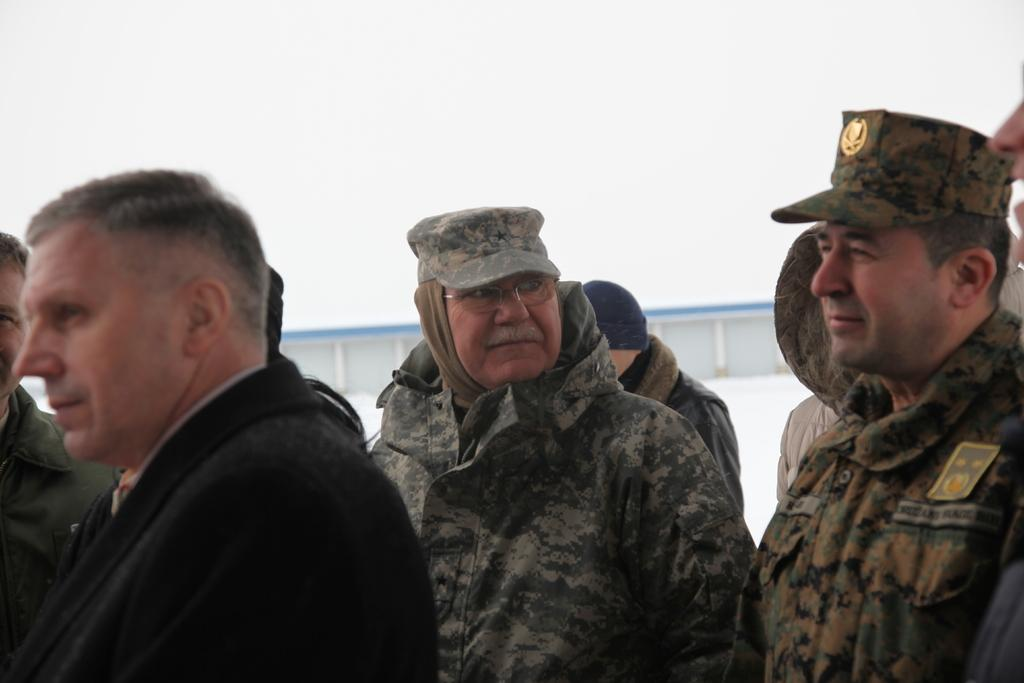How many people are in the group that is visible in the image? There is a group of people standing in the image. Can you describe any specific clothing items that some of the people are wearing? Two people in the group are wearing hats. Is there any other notable accessory or item visible on one of the people in the image? Yes, there is a badge attached to a shirt in the image. What type of flowers are being touched by the people in the image? There are no flowers present in the image. What government policy is being discussed by the group in the image? The image does not provide any information about a discussion or government policy. 